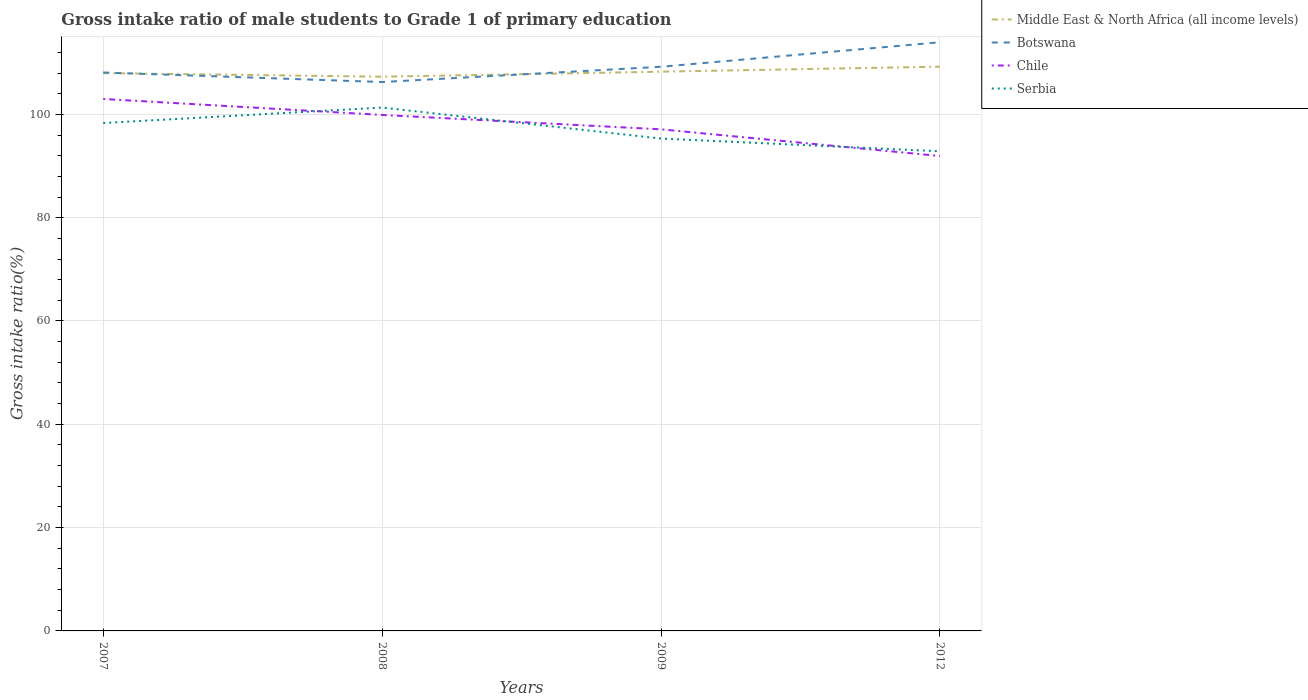How many different coloured lines are there?
Your answer should be very brief. 4. Is the number of lines equal to the number of legend labels?
Your answer should be compact. Yes. Across all years, what is the maximum gross intake ratio in Middle East & North Africa (all income levels)?
Your response must be concise. 107.3. In which year was the gross intake ratio in Botswana maximum?
Make the answer very short. 2008. What is the total gross intake ratio in Serbia in the graph?
Offer a very short reply. 3.01. What is the difference between the highest and the second highest gross intake ratio in Middle East & North Africa (all income levels)?
Your response must be concise. 1.94. What is the difference between the highest and the lowest gross intake ratio in Middle East & North Africa (all income levels)?
Give a very brief answer. 2. How many years are there in the graph?
Provide a succinct answer. 4. What is the difference between two consecutive major ticks on the Y-axis?
Give a very brief answer. 20. How many legend labels are there?
Your answer should be compact. 4. How are the legend labels stacked?
Ensure brevity in your answer.  Vertical. What is the title of the graph?
Your answer should be compact. Gross intake ratio of male students to Grade 1 of primary education. What is the label or title of the X-axis?
Provide a short and direct response. Years. What is the label or title of the Y-axis?
Provide a succinct answer. Gross intake ratio(%). What is the Gross intake ratio(%) in Middle East & North Africa (all income levels) in 2007?
Provide a short and direct response. 107.99. What is the Gross intake ratio(%) of Botswana in 2007?
Ensure brevity in your answer.  108.11. What is the Gross intake ratio(%) of Chile in 2007?
Make the answer very short. 102.99. What is the Gross intake ratio(%) of Serbia in 2007?
Provide a short and direct response. 98.33. What is the Gross intake ratio(%) of Middle East & North Africa (all income levels) in 2008?
Offer a very short reply. 107.3. What is the Gross intake ratio(%) in Botswana in 2008?
Provide a short and direct response. 106.26. What is the Gross intake ratio(%) in Chile in 2008?
Your response must be concise. 99.89. What is the Gross intake ratio(%) of Serbia in 2008?
Keep it short and to the point. 101.32. What is the Gross intake ratio(%) of Middle East & North Africa (all income levels) in 2009?
Your answer should be very brief. 108.27. What is the Gross intake ratio(%) of Botswana in 2009?
Ensure brevity in your answer.  109.22. What is the Gross intake ratio(%) of Chile in 2009?
Give a very brief answer. 97.1. What is the Gross intake ratio(%) in Serbia in 2009?
Your response must be concise. 95.32. What is the Gross intake ratio(%) of Middle East & North Africa (all income levels) in 2012?
Your answer should be very brief. 109.24. What is the Gross intake ratio(%) of Botswana in 2012?
Provide a succinct answer. 113.96. What is the Gross intake ratio(%) of Chile in 2012?
Keep it short and to the point. 91.94. What is the Gross intake ratio(%) in Serbia in 2012?
Offer a very short reply. 92.86. Across all years, what is the maximum Gross intake ratio(%) in Middle East & North Africa (all income levels)?
Provide a succinct answer. 109.24. Across all years, what is the maximum Gross intake ratio(%) of Botswana?
Your response must be concise. 113.96. Across all years, what is the maximum Gross intake ratio(%) of Chile?
Offer a terse response. 102.99. Across all years, what is the maximum Gross intake ratio(%) of Serbia?
Your response must be concise. 101.32. Across all years, what is the minimum Gross intake ratio(%) in Middle East & North Africa (all income levels)?
Provide a short and direct response. 107.3. Across all years, what is the minimum Gross intake ratio(%) in Botswana?
Offer a very short reply. 106.26. Across all years, what is the minimum Gross intake ratio(%) in Chile?
Your answer should be very brief. 91.94. Across all years, what is the minimum Gross intake ratio(%) in Serbia?
Make the answer very short. 92.86. What is the total Gross intake ratio(%) in Middle East & North Africa (all income levels) in the graph?
Provide a succinct answer. 432.79. What is the total Gross intake ratio(%) in Botswana in the graph?
Offer a very short reply. 437.56. What is the total Gross intake ratio(%) in Chile in the graph?
Your answer should be very brief. 391.92. What is the total Gross intake ratio(%) of Serbia in the graph?
Your answer should be very brief. 387.83. What is the difference between the Gross intake ratio(%) of Middle East & North Africa (all income levels) in 2007 and that in 2008?
Offer a very short reply. 0.69. What is the difference between the Gross intake ratio(%) of Botswana in 2007 and that in 2008?
Your response must be concise. 1.85. What is the difference between the Gross intake ratio(%) of Chile in 2007 and that in 2008?
Offer a terse response. 3.1. What is the difference between the Gross intake ratio(%) of Serbia in 2007 and that in 2008?
Offer a very short reply. -2.99. What is the difference between the Gross intake ratio(%) in Middle East & North Africa (all income levels) in 2007 and that in 2009?
Keep it short and to the point. -0.28. What is the difference between the Gross intake ratio(%) in Botswana in 2007 and that in 2009?
Your answer should be compact. -1.11. What is the difference between the Gross intake ratio(%) of Chile in 2007 and that in 2009?
Provide a short and direct response. 5.88. What is the difference between the Gross intake ratio(%) of Serbia in 2007 and that in 2009?
Offer a very short reply. 3.01. What is the difference between the Gross intake ratio(%) of Middle East & North Africa (all income levels) in 2007 and that in 2012?
Provide a succinct answer. -1.25. What is the difference between the Gross intake ratio(%) in Botswana in 2007 and that in 2012?
Make the answer very short. -5.85. What is the difference between the Gross intake ratio(%) of Chile in 2007 and that in 2012?
Provide a short and direct response. 11.05. What is the difference between the Gross intake ratio(%) in Serbia in 2007 and that in 2012?
Provide a succinct answer. 5.47. What is the difference between the Gross intake ratio(%) of Middle East & North Africa (all income levels) in 2008 and that in 2009?
Provide a short and direct response. -0.97. What is the difference between the Gross intake ratio(%) in Botswana in 2008 and that in 2009?
Provide a short and direct response. -2.96. What is the difference between the Gross intake ratio(%) in Chile in 2008 and that in 2009?
Keep it short and to the point. 2.79. What is the difference between the Gross intake ratio(%) of Serbia in 2008 and that in 2009?
Offer a very short reply. 6. What is the difference between the Gross intake ratio(%) in Middle East & North Africa (all income levels) in 2008 and that in 2012?
Keep it short and to the point. -1.94. What is the difference between the Gross intake ratio(%) of Chile in 2008 and that in 2012?
Your answer should be compact. 7.95. What is the difference between the Gross intake ratio(%) of Serbia in 2008 and that in 2012?
Ensure brevity in your answer.  8.46. What is the difference between the Gross intake ratio(%) of Middle East & North Africa (all income levels) in 2009 and that in 2012?
Keep it short and to the point. -0.97. What is the difference between the Gross intake ratio(%) of Botswana in 2009 and that in 2012?
Keep it short and to the point. -4.74. What is the difference between the Gross intake ratio(%) of Chile in 2009 and that in 2012?
Provide a succinct answer. 5.16. What is the difference between the Gross intake ratio(%) in Serbia in 2009 and that in 2012?
Provide a succinct answer. 2.46. What is the difference between the Gross intake ratio(%) in Middle East & North Africa (all income levels) in 2007 and the Gross intake ratio(%) in Botswana in 2008?
Your response must be concise. 1.72. What is the difference between the Gross intake ratio(%) of Middle East & North Africa (all income levels) in 2007 and the Gross intake ratio(%) of Chile in 2008?
Your answer should be compact. 8.1. What is the difference between the Gross intake ratio(%) in Middle East & North Africa (all income levels) in 2007 and the Gross intake ratio(%) in Serbia in 2008?
Offer a very short reply. 6.67. What is the difference between the Gross intake ratio(%) in Botswana in 2007 and the Gross intake ratio(%) in Chile in 2008?
Provide a succinct answer. 8.22. What is the difference between the Gross intake ratio(%) in Botswana in 2007 and the Gross intake ratio(%) in Serbia in 2008?
Keep it short and to the point. 6.79. What is the difference between the Gross intake ratio(%) in Middle East & North Africa (all income levels) in 2007 and the Gross intake ratio(%) in Botswana in 2009?
Your response must be concise. -1.23. What is the difference between the Gross intake ratio(%) of Middle East & North Africa (all income levels) in 2007 and the Gross intake ratio(%) of Chile in 2009?
Ensure brevity in your answer.  10.88. What is the difference between the Gross intake ratio(%) of Middle East & North Africa (all income levels) in 2007 and the Gross intake ratio(%) of Serbia in 2009?
Keep it short and to the point. 12.67. What is the difference between the Gross intake ratio(%) in Botswana in 2007 and the Gross intake ratio(%) in Chile in 2009?
Your response must be concise. 11.01. What is the difference between the Gross intake ratio(%) in Botswana in 2007 and the Gross intake ratio(%) in Serbia in 2009?
Ensure brevity in your answer.  12.79. What is the difference between the Gross intake ratio(%) in Chile in 2007 and the Gross intake ratio(%) in Serbia in 2009?
Ensure brevity in your answer.  7.67. What is the difference between the Gross intake ratio(%) in Middle East & North Africa (all income levels) in 2007 and the Gross intake ratio(%) in Botswana in 2012?
Provide a succinct answer. -5.98. What is the difference between the Gross intake ratio(%) in Middle East & North Africa (all income levels) in 2007 and the Gross intake ratio(%) in Chile in 2012?
Your answer should be very brief. 16.05. What is the difference between the Gross intake ratio(%) of Middle East & North Africa (all income levels) in 2007 and the Gross intake ratio(%) of Serbia in 2012?
Ensure brevity in your answer.  15.13. What is the difference between the Gross intake ratio(%) in Botswana in 2007 and the Gross intake ratio(%) in Chile in 2012?
Offer a terse response. 16.17. What is the difference between the Gross intake ratio(%) of Botswana in 2007 and the Gross intake ratio(%) of Serbia in 2012?
Make the answer very short. 15.26. What is the difference between the Gross intake ratio(%) of Chile in 2007 and the Gross intake ratio(%) of Serbia in 2012?
Keep it short and to the point. 10.13. What is the difference between the Gross intake ratio(%) of Middle East & North Africa (all income levels) in 2008 and the Gross intake ratio(%) of Botswana in 2009?
Offer a terse response. -1.92. What is the difference between the Gross intake ratio(%) in Middle East & North Africa (all income levels) in 2008 and the Gross intake ratio(%) in Chile in 2009?
Your answer should be very brief. 10.19. What is the difference between the Gross intake ratio(%) of Middle East & North Africa (all income levels) in 2008 and the Gross intake ratio(%) of Serbia in 2009?
Provide a succinct answer. 11.98. What is the difference between the Gross intake ratio(%) of Botswana in 2008 and the Gross intake ratio(%) of Chile in 2009?
Offer a terse response. 9.16. What is the difference between the Gross intake ratio(%) in Botswana in 2008 and the Gross intake ratio(%) in Serbia in 2009?
Ensure brevity in your answer.  10.94. What is the difference between the Gross intake ratio(%) of Chile in 2008 and the Gross intake ratio(%) of Serbia in 2009?
Your answer should be very brief. 4.57. What is the difference between the Gross intake ratio(%) in Middle East & North Africa (all income levels) in 2008 and the Gross intake ratio(%) in Botswana in 2012?
Offer a very short reply. -6.67. What is the difference between the Gross intake ratio(%) in Middle East & North Africa (all income levels) in 2008 and the Gross intake ratio(%) in Chile in 2012?
Ensure brevity in your answer.  15.36. What is the difference between the Gross intake ratio(%) of Middle East & North Africa (all income levels) in 2008 and the Gross intake ratio(%) of Serbia in 2012?
Your response must be concise. 14.44. What is the difference between the Gross intake ratio(%) in Botswana in 2008 and the Gross intake ratio(%) in Chile in 2012?
Your response must be concise. 14.32. What is the difference between the Gross intake ratio(%) of Botswana in 2008 and the Gross intake ratio(%) of Serbia in 2012?
Keep it short and to the point. 13.4. What is the difference between the Gross intake ratio(%) of Chile in 2008 and the Gross intake ratio(%) of Serbia in 2012?
Offer a very short reply. 7.03. What is the difference between the Gross intake ratio(%) of Middle East & North Africa (all income levels) in 2009 and the Gross intake ratio(%) of Botswana in 2012?
Your answer should be very brief. -5.7. What is the difference between the Gross intake ratio(%) in Middle East & North Africa (all income levels) in 2009 and the Gross intake ratio(%) in Chile in 2012?
Provide a succinct answer. 16.33. What is the difference between the Gross intake ratio(%) of Middle East & North Africa (all income levels) in 2009 and the Gross intake ratio(%) of Serbia in 2012?
Give a very brief answer. 15.41. What is the difference between the Gross intake ratio(%) in Botswana in 2009 and the Gross intake ratio(%) in Chile in 2012?
Provide a succinct answer. 17.28. What is the difference between the Gross intake ratio(%) of Botswana in 2009 and the Gross intake ratio(%) of Serbia in 2012?
Give a very brief answer. 16.36. What is the difference between the Gross intake ratio(%) in Chile in 2009 and the Gross intake ratio(%) in Serbia in 2012?
Ensure brevity in your answer.  4.25. What is the average Gross intake ratio(%) in Middle East & North Africa (all income levels) per year?
Make the answer very short. 108.2. What is the average Gross intake ratio(%) of Botswana per year?
Offer a very short reply. 109.39. What is the average Gross intake ratio(%) of Chile per year?
Provide a succinct answer. 97.98. What is the average Gross intake ratio(%) of Serbia per year?
Give a very brief answer. 96.96. In the year 2007, what is the difference between the Gross intake ratio(%) of Middle East & North Africa (all income levels) and Gross intake ratio(%) of Botswana?
Keep it short and to the point. -0.13. In the year 2007, what is the difference between the Gross intake ratio(%) in Middle East & North Africa (all income levels) and Gross intake ratio(%) in Chile?
Offer a very short reply. 5. In the year 2007, what is the difference between the Gross intake ratio(%) in Middle East & North Africa (all income levels) and Gross intake ratio(%) in Serbia?
Provide a short and direct response. 9.66. In the year 2007, what is the difference between the Gross intake ratio(%) of Botswana and Gross intake ratio(%) of Chile?
Make the answer very short. 5.13. In the year 2007, what is the difference between the Gross intake ratio(%) in Botswana and Gross intake ratio(%) in Serbia?
Provide a short and direct response. 9.78. In the year 2007, what is the difference between the Gross intake ratio(%) of Chile and Gross intake ratio(%) of Serbia?
Keep it short and to the point. 4.66. In the year 2008, what is the difference between the Gross intake ratio(%) in Middle East & North Africa (all income levels) and Gross intake ratio(%) in Botswana?
Give a very brief answer. 1.03. In the year 2008, what is the difference between the Gross intake ratio(%) of Middle East & North Africa (all income levels) and Gross intake ratio(%) of Chile?
Your answer should be very brief. 7.41. In the year 2008, what is the difference between the Gross intake ratio(%) in Middle East & North Africa (all income levels) and Gross intake ratio(%) in Serbia?
Give a very brief answer. 5.98. In the year 2008, what is the difference between the Gross intake ratio(%) of Botswana and Gross intake ratio(%) of Chile?
Your answer should be very brief. 6.37. In the year 2008, what is the difference between the Gross intake ratio(%) of Botswana and Gross intake ratio(%) of Serbia?
Your answer should be very brief. 4.94. In the year 2008, what is the difference between the Gross intake ratio(%) in Chile and Gross intake ratio(%) in Serbia?
Offer a very short reply. -1.43. In the year 2009, what is the difference between the Gross intake ratio(%) of Middle East & North Africa (all income levels) and Gross intake ratio(%) of Botswana?
Your answer should be very brief. -0.95. In the year 2009, what is the difference between the Gross intake ratio(%) in Middle East & North Africa (all income levels) and Gross intake ratio(%) in Chile?
Give a very brief answer. 11.16. In the year 2009, what is the difference between the Gross intake ratio(%) of Middle East & North Africa (all income levels) and Gross intake ratio(%) of Serbia?
Provide a short and direct response. 12.95. In the year 2009, what is the difference between the Gross intake ratio(%) of Botswana and Gross intake ratio(%) of Chile?
Give a very brief answer. 12.11. In the year 2009, what is the difference between the Gross intake ratio(%) of Botswana and Gross intake ratio(%) of Serbia?
Make the answer very short. 13.9. In the year 2009, what is the difference between the Gross intake ratio(%) of Chile and Gross intake ratio(%) of Serbia?
Offer a terse response. 1.78. In the year 2012, what is the difference between the Gross intake ratio(%) of Middle East & North Africa (all income levels) and Gross intake ratio(%) of Botswana?
Keep it short and to the point. -4.72. In the year 2012, what is the difference between the Gross intake ratio(%) of Middle East & North Africa (all income levels) and Gross intake ratio(%) of Chile?
Your answer should be compact. 17.3. In the year 2012, what is the difference between the Gross intake ratio(%) of Middle East & North Africa (all income levels) and Gross intake ratio(%) of Serbia?
Keep it short and to the point. 16.38. In the year 2012, what is the difference between the Gross intake ratio(%) in Botswana and Gross intake ratio(%) in Chile?
Offer a very short reply. 22.02. In the year 2012, what is the difference between the Gross intake ratio(%) in Botswana and Gross intake ratio(%) in Serbia?
Provide a short and direct response. 21.1. In the year 2012, what is the difference between the Gross intake ratio(%) of Chile and Gross intake ratio(%) of Serbia?
Make the answer very short. -0.92. What is the ratio of the Gross intake ratio(%) in Middle East & North Africa (all income levels) in 2007 to that in 2008?
Your response must be concise. 1.01. What is the ratio of the Gross intake ratio(%) of Botswana in 2007 to that in 2008?
Offer a terse response. 1.02. What is the ratio of the Gross intake ratio(%) in Chile in 2007 to that in 2008?
Offer a very short reply. 1.03. What is the ratio of the Gross intake ratio(%) of Serbia in 2007 to that in 2008?
Your response must be concise. 0.97. What is the ratio of the Gross intake ratio(%) in Middle East & North Africa (all income levels) in 2007 to that in 2009?
Your answer should be very brief. 1. What is the ratio of the Gross intake ratio(%) in Chile in 2007 to that in 2009?
Provide a short and direct response. 1.06. What is the ratio of the Gross intake ratio(%) of Serbia in 2007 to that in 2009?
Your answer should be very brief. 1.03. What is the ratio of the Gross intake ratio(%) in Middle East & North Africa (all income levels) in 2007 to that in 2012?
Your response must be concise. 0.99. What is the ratio of the Gross intake ratio(%) of Botswana in 2007 to that in 2012?
Your response must be concise. 0.95. What is the ratio of the Gross intake ratio(%) in Chile in 2007 to that in 2012?
Your answer should be compact. 1.12. What is the ratio of the Gross intake ratio(%) of Serbia in 2007 to that in 2012?
Keep it short and to the point. 1.06. What is the ratio of the Gross intake ratio(%) in Middle East & North Africa (all income levels) in 2008 to that in 2009?
Offer a terse response. 0.99. What is the ratio of the Gross intake ratio(%) of Botswana in 2008 to that in 2009?
Offer a terse response. 0.97. What is the ratio of the Gross intake ratio(%) in Chile in 2008 to that in 2009?
Provide a short and direct response. 1.03. What is the ratio of the Gross intake ratio(%) in Serbia in 2008 to that in 2009?
Offer a very short reply. 1.06. What is the ratio of the Gross intake ratio(%) in Middle East & North Africa (all income levels) in 2008 to that in 2012?
Ensure brevity in your answer.  0.98. What is the ratio of the Gross intake ratio(%) in Botswana in 2008 to that in 2012?
Offer a terse response. 0.93. What is the ratio of the Gross intake ratio(%) of Chile in 2008 to that in 2012?
Offer a very short reply. 1.09. What is the ratio of the Gross intake ratio(%) of Serbia in 2008 to that in 2012?
Provide a short and direct response. 1.09. What is the ratio of the Gross intake ratio(%) in Middle East & North Africa (all income levels) in 2009 to that in 2012?
Provide a short and direct response. 0.99. What is the ratio of the Gross intake ratio(%) of Botswana in 2009 to that in 2012?
Ensure brevity in your answer.  0.96. What is the ratio of the Gross intake ratio(%) of Chile in 2009 to that in 2012?
Give a very brief answer. 1.06. What is the ratio of the Gross intake ratio(%) of Serbia in 2009 to that in 2012?
Provide a short and direct response. 1.03. What is the difference between the highest and the second highest Gross intake ratio(%) of Middle East & North Africa (all income levels)?
Keep it short and to the point. 0.97. What is the difference between the highest and the second highest Gross intake ratio(%) in Botswana?
Your answer should be compact. 4.74. What is the difference between the highest and the second highest Gross intake ratio(%) of Chile?
Your answer should be compact. 3.1. What is the difference between the highest and the second highest Gross intake ratio(%) in Serbia?
Ensure brevity in your answer.  2.99. What is the difference between the highest and the lowest Gross intake ratio(%) in Middle East & North Africa (all income levels)?
Give a very brief answer. 1.94. What is the difference between the highest and the lowest Gross intake ratio(%) of Botswana?
Offer a terse response. 7.7. What is the difference between the highest and the lowest Gross intake ratio(%) of Chile?
Give a very brief answer. 11.05. What is the difference between the highest and the lowest Gross intake ratio(%) of Serbia?
Your answer should be very brief. 8.46. 